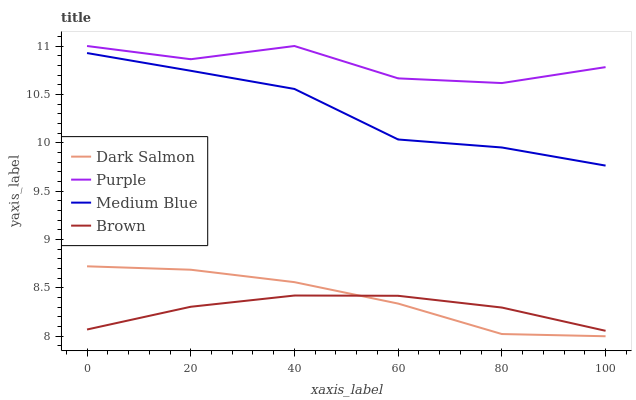Does Brown have the minimum area under the curve?
Answer yes or no. Yes. Does Purple have the maximum area under the curve?
Answer yes or no. Yes. Does Medium Blue have the minimum area under the curve?
Answer yes or no. No. Does Medium Blue have the maximum area under the curve?
Answer yes or no. No. Is Brown the smoothest?
Answer yes or no. Yes. Is Purple the roughest?
Answer yes or no. Yes. Is Medium Blue the smoothest?
Answer yes or no. No. Is Medium Blue the roughest?
Answer yes or no. No. Does Dark Salmon have the lowest value?
Answer yes or no. Yes. Does Brown have the lowest value?
Answer yes or no. No. Does Purple have the highest value?
Answer yes or no. Yes. Does Medium Blue have the highest value?
Answer yes or no. No. Is Medium Blue less than Purple?
Answer yes or no. Yes. Is Medium Blue greater than Dark Salmon?
Answer yes or no. Yes. Does Dark Salmon intersect Brown?
Answer yes or no. Yes. Is Dark Salmon less than Brown?
Answer yes or no. No. Is Dark Salmon greater than Brown?
Answer yes or no. No. Does Medium Blue intersect Purple?
Answer yes or no. No. 